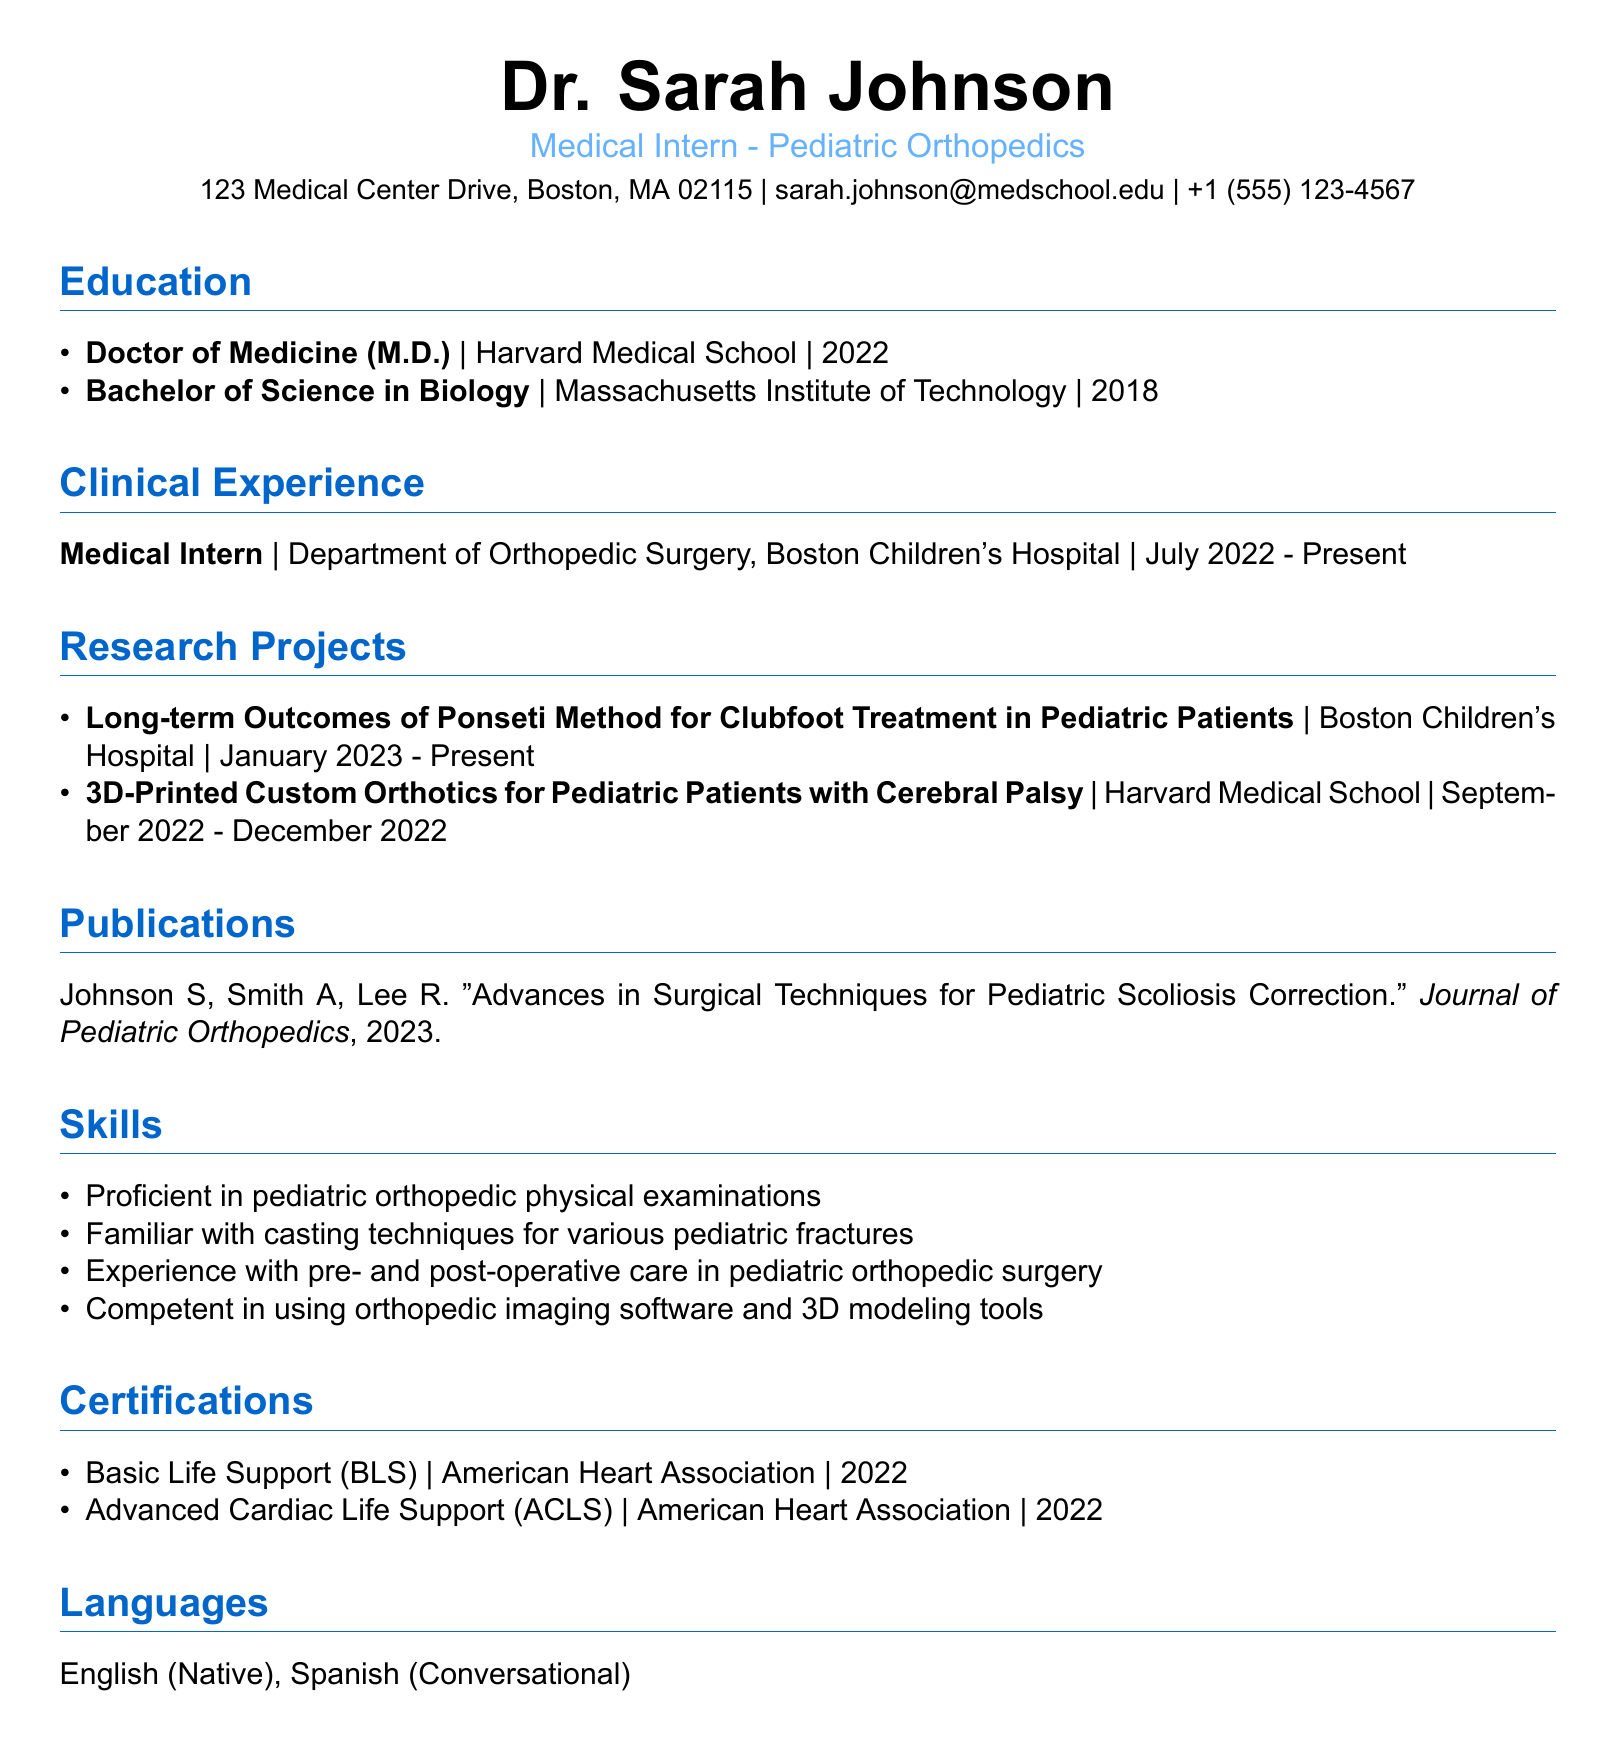what is the name of the intern? The document lists the name of the intern as the first piece of information under personal details.
Answer: Dr. Sarah Johnson which hospital is associated with the current clinical experience? The clinical experience section specifies the institution where the medical intern is currently working.
Answer: Boston Children's Hospital what is the title of the research project completed at Harvard Medical School? The research projects section includes two projects, one of which was conducted at Harvard Medical School.
Answer: 3D-Printed Custom Orthotics for Pediatric Patients with Cerebral Palsy how many people co-authored the publication listed? The publication section provides the names of the authors, revealing the number of individuals involved.
Answer: 3 in what year did Dr. Sarah Johnson complete her medical degree? The education section states the graduation year for the Doctor of Medicine degree.
Answer: 2022 what certification was issued by the American Heart Association in 2022? The certifications section lists all certifications along with their issuers and dates.
Answer: Basic Life Support (BLS) what type of medical intern is Dr. Sarah Johnson? The introductory section of the document specifies the current position of the intern within the orthopedic specialty.
Answer: Pediatric Orthopedics which imaging software is the intern competent in? The skills section mentions general skills but does not specify the exact software used.
Answer: orthopedic imaging software what is the duration of the current research project? The research projects section provides the starting date of the ongoing project.
Answer: January 2023 - Present 